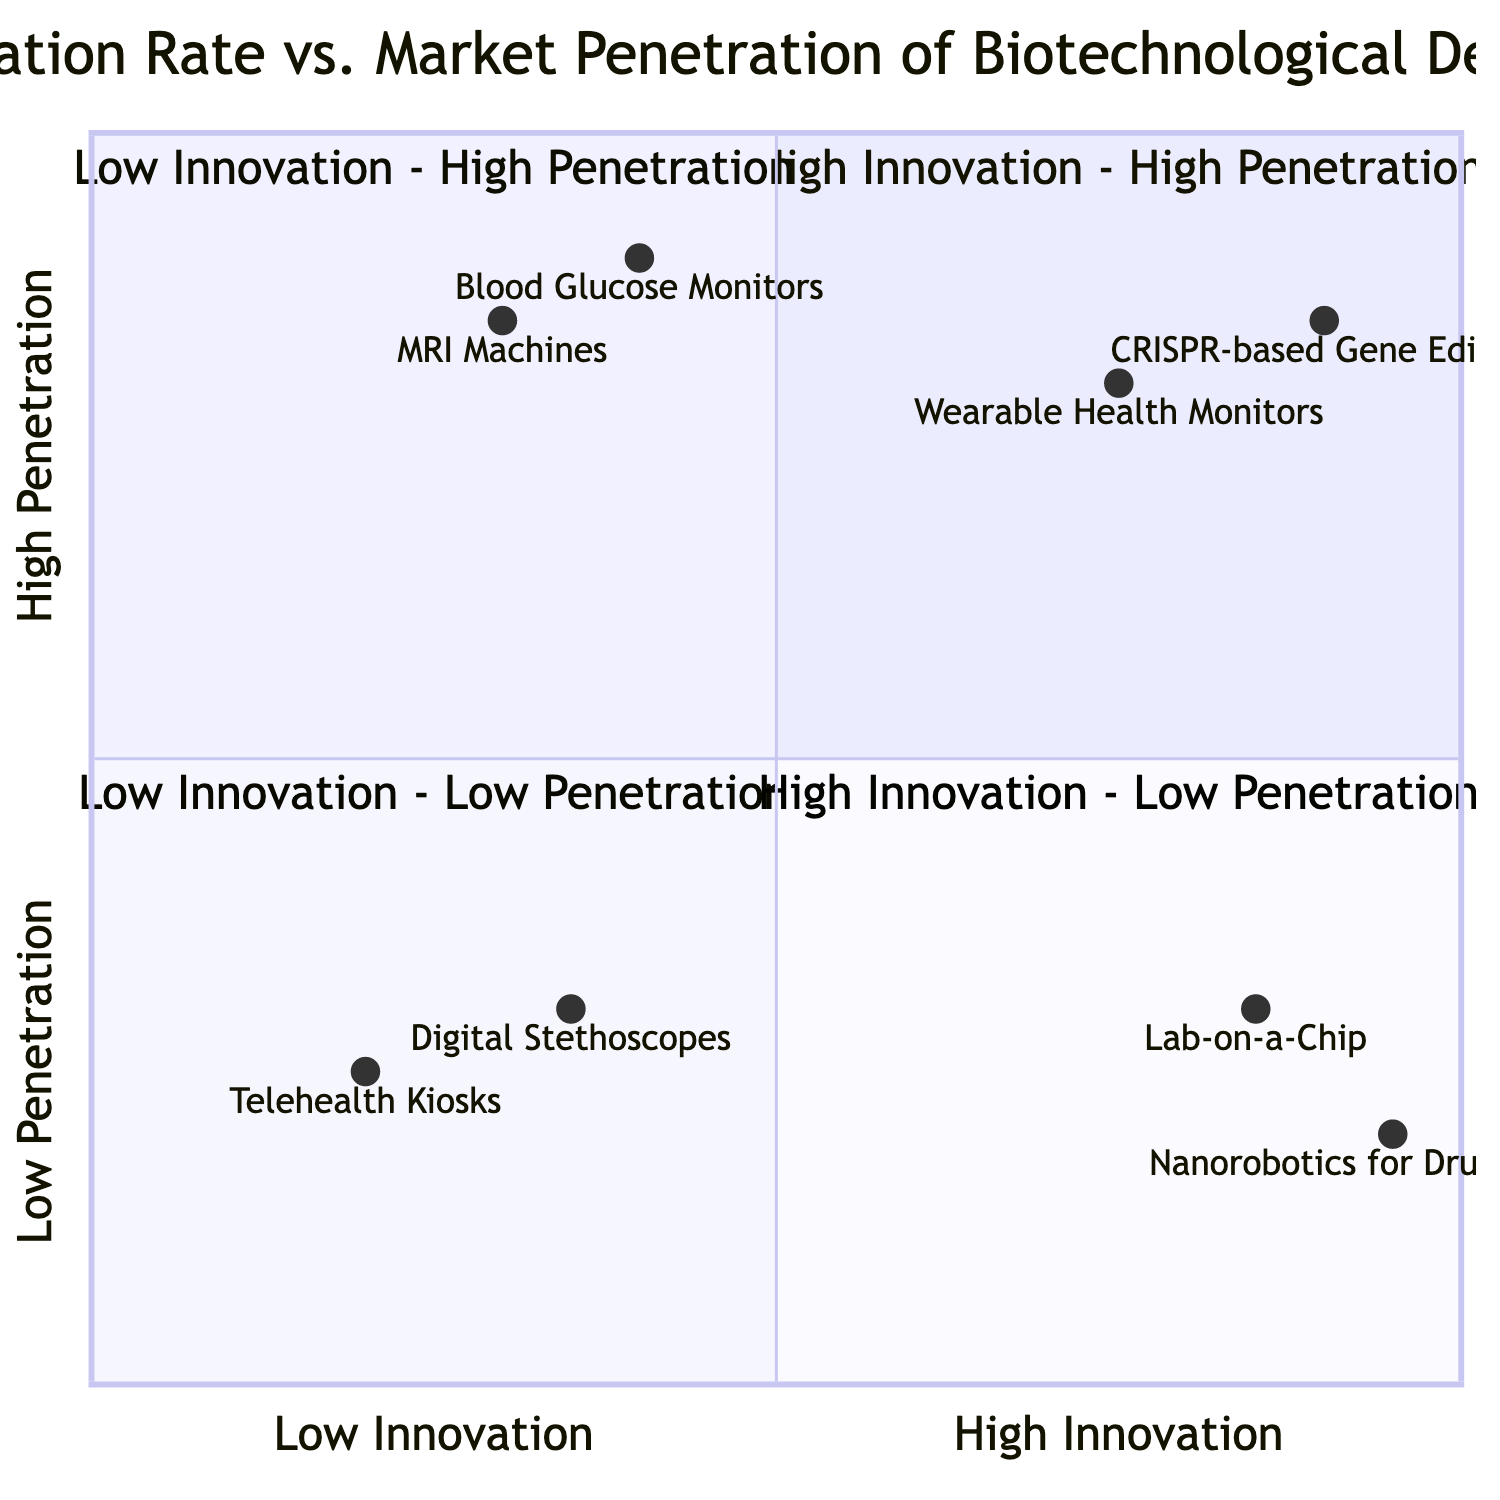What devices are in the High Innovation - High Penetration quadrant? The High Innovation - High Penetration quadrant contains two devices: CRISPR-based Gene Editing and Wearable Health Monitors.
Answer: CRISPR-based Gene Editing, Wearable Health Monitors How many devices are in the Low Innovation - Low Penetration quadrant? There are two devices in the Low Innovation - Low Penetration quadrant: Telehealth Kiosks and Digital Stethoscopes.
Answer: 2 Which device has the highest innovation rate? Nanorobotics for Drug Delivery has the highest innovation rate, indicated by its position closest to the high innovation end of the x-axis. Its innovation rate is 0.95.
Answer: Nanorobotics for Drug Delivery What is the market penetration of Blood Glucose Monitors? Blood Glucose Monitors are located in the Low Innovation - High Penetration quadrant, where the corresponding market penetration value is 0.9.
Answer: 0.9 How does the innovation rate of Lab-on-a-Chip compare with that of MRI Machines? Lab-on-a-Chip has a higher innovation rate (0.85) compared to MRI Machines (0.3), indicating that Lab-on-a-Chip is more innovative despite having lower market penetration.
Answer: Lab-on-a-Chip has a higher innovation rate What is the penetration level of Telehealth Kiosks? Telehealth Kiosks have a market penetration level of 0.25, placing them in the Low Innovation - Low Penetration quadrant.
Answer: 0.25 Which device has a similar innovation rate to Wearable Health Monitors? The innovation rate of Blood Glucose Monitors (0.4) is lower than that of Wearable Health Monitors (0.75), so a closer comparison is with none from the same quadrant or others. No device has a similar rate.
Answer: None Are there any devices in the Low Innovation - High Penetration quadrant? Yes, the devices in this quadrant are Blood Glucose Monitors and MRI Machines, which both have high market penetration.
Answer: Yes Which device has the lowest market penetration value? Telehealth Kiosks have the lowest market penetration value at 0.25, located in the Low Innovation - Low Penetration quadrant.
Answer: Telehealth Kiosks 